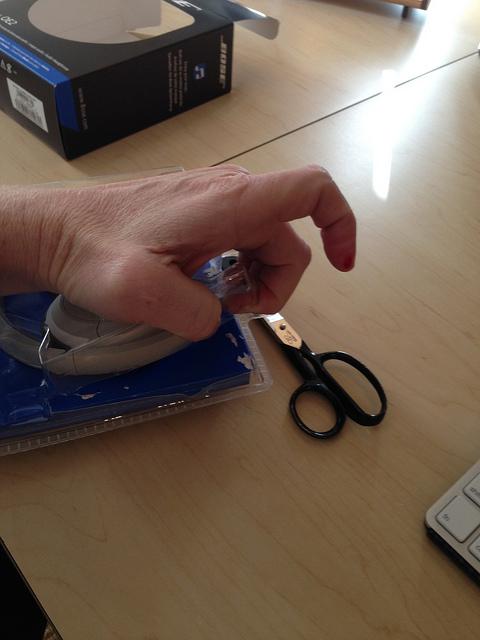Is the package hard to open?
Answer briefly. Yes. What is the man doing with his hands?
Be succinct. Opening package. Is there a piece of plywood in the picture?
Answer briefly. No. Do you use this scissors in your left or right hand?
Write a very short answer. Right. What is on the desk?
Keep it brief. Scissors. What color is the table?
Quick response, please. Brown. What sort of devices are on the desk?
Short answer required. Scissors. How many plugs can you see?
Quick response, please. 0. What color are the handles of the scissors?
Quick response, please. Black. Is the main object a cell phone?
Be succinct. No. Where are the scissors?
Write a very short answer. Table. 